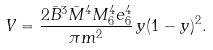Convert formula to latex. <formula><loc_0><loc_0><loc_500><loc_500>V = \frac { 2 \bar { B } ^ { 3 } \bar { M } ^ { 4 } M _ { 6 } ^ { 4 } e _ { 6 } ^ { 4 } } { \pi m ^ { 2 } } \, y ( 1 - y ) ^ { 2 } .</formula> 